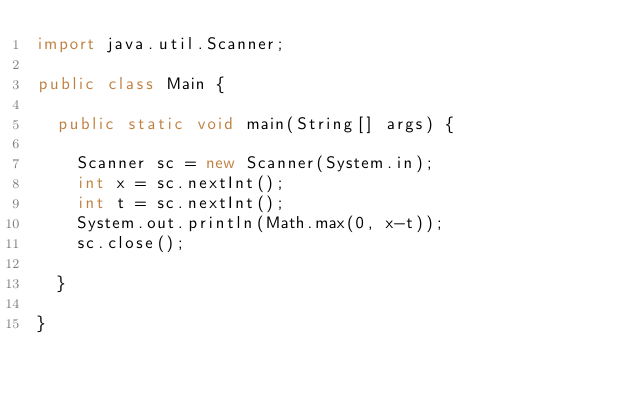<code> <loc_0><loc_0><loc_500><loc_500><_Java_>import java.util.Scanner;

public class Main {

	public static void main(String[] args) {

		Scanner sc = new Scanner(System.in);
		int x = sc.nextInt();
		int t = sc.nextInt();
		System.out.println(Math.max(0, x-t));
		sc.close();

	}

}</code> 